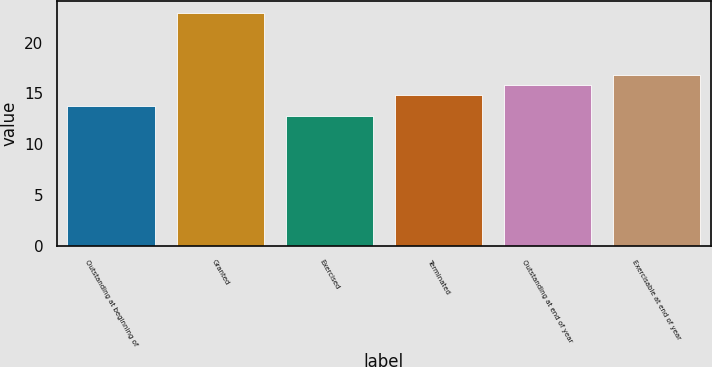Convert chart. <chart><loc_0><loc_0><loc_500><loc_500><bar_chart><fcel>Outstanding at beginning of<fcel>Granted<fcel>Exercised<fcel>Terminated<fcel>Outstanding at end of year<fcel>Exercisable at end of year<nl><fcel>13.8<fcel>22.93<fcel>12.79<fcel>14.81<fcel>15.82<fcel>16.83<nl></chart> 